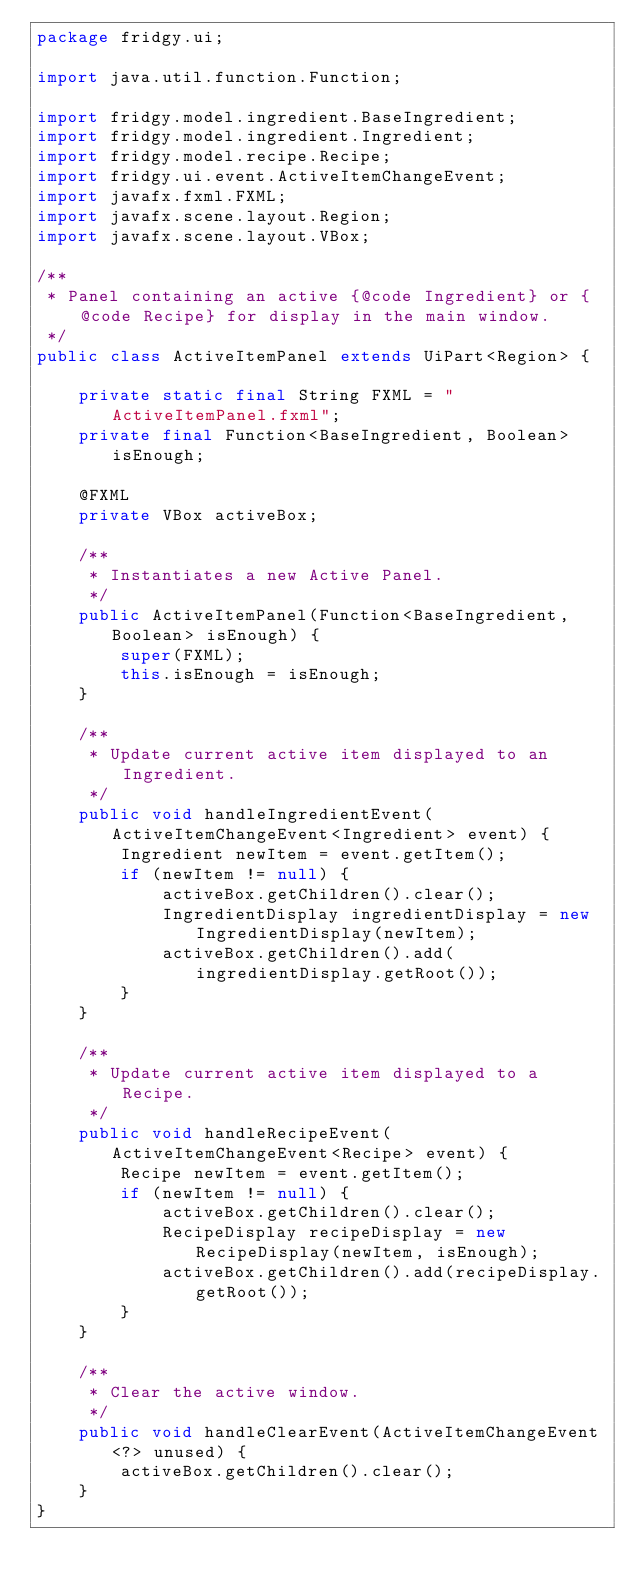Convert code to text. <code><loc_0><loc_0><loc_500><loc_500><_Java_>package fridgy.ui;

import java.util.function.Function;

import fridgy.model.ingredient.BaseIngredient;
import fridgy.model.ingredient.Ingredient;
import fridgy.model.recipe.Recipe;
import fridgy.ui.event.ActiveItemChangeEvent;
import javafx.fxml.FXML;
import javafx.scene.layout.Region;
import javafx.scene.layout.VBox;

/**
 * Panel containing an active {@code Ingredient} or {@code Recipe} for display in the main window.
 */
public class ActiveItemPanel extends UiPart<Region> {

    private static final String FXML = "ActiveItemPanel.fxml";
    private final Function<BaseIngredient, Boolean> isEnough;

    @FXML
    private VBox activeBox;

    /**
     * Instantiates a new Active Panel.
     */
    public ActiveItemPanel(Function<BaseIngredient, Boolean> isEnough) {
        super(FXML);
        this.isEnough = isEnough;
    }

    /**
     * Update current active item displayed to an Ingredient.
     */
    public void handleIngredientEvent(ActiveItemChangeEvent<Ingredient> event) {
        Ingredient newItem = event.getItem();
        if (newItem != null) {
            activeBox.getChildren().clear();
            IngredientDisplay ingredientDisplay = new IngredientDisplay(newItem);
            activeBox.getChildren().add(ingredientDisplay.getRoot());
        }
    }

    /**
     * Update current active item displayed to a Recipe.
     */
    public void handleRecipeEvent(ActiveItemChangeEvent<Recipe> event) {
        Recipe newItem = event.getItem();
        if (newItem != null) {
            activeBox.getChildren().clear();
            RecipeDisplay recipeDisplay = new RecipeDisplay(newItem, isEnough);
            activeBox.getChildren().add(recipeDisplay.getRoot());
        }
    }

    /**
     * Clear the active window.
     */
    public void handleClearEvent(ActiveItemChangeEvent<?> unused) {
        activeBox.getChildren().clear();
    }
}
</code> 